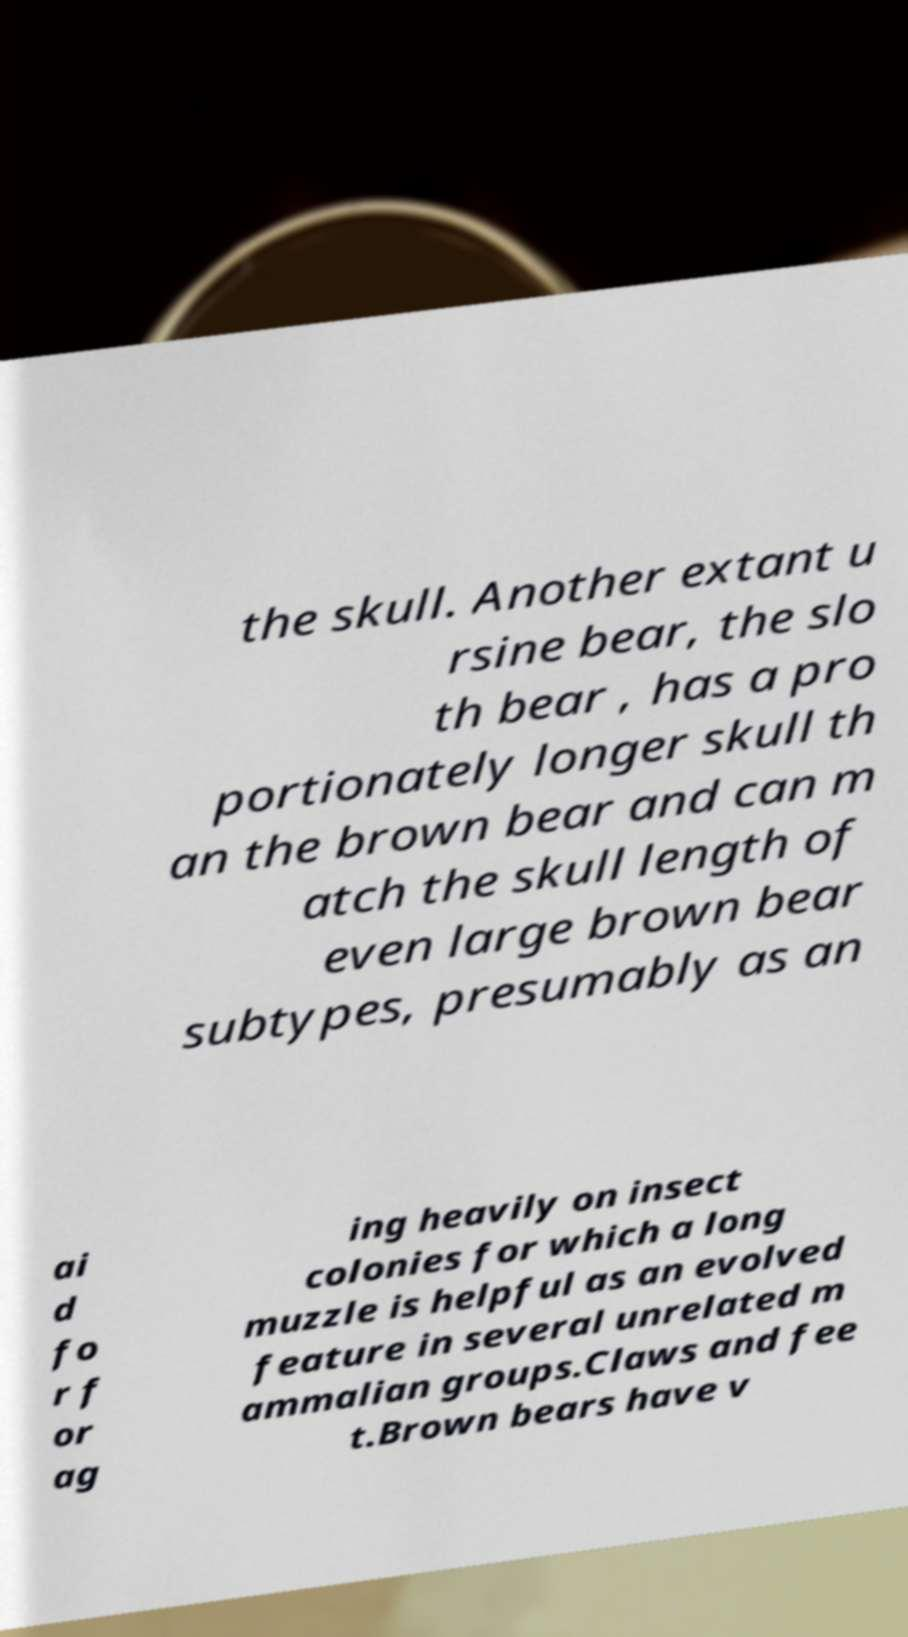There's text embedded in this image that I need extracted. Can you transcribe it verbatim? the skull. Another extant u rsine bear, the slo th bear , has a pro portionately longer skull th an the brown bear and can m atch the skull length of even large brown bear subtypes, presumably as an ai d fo r f or ag ing heavily on insect colonies for which a long muzzle is helpful as an evolved feature in several unrelated m ammalian groups.Claws and fee t.Brown bears have v 